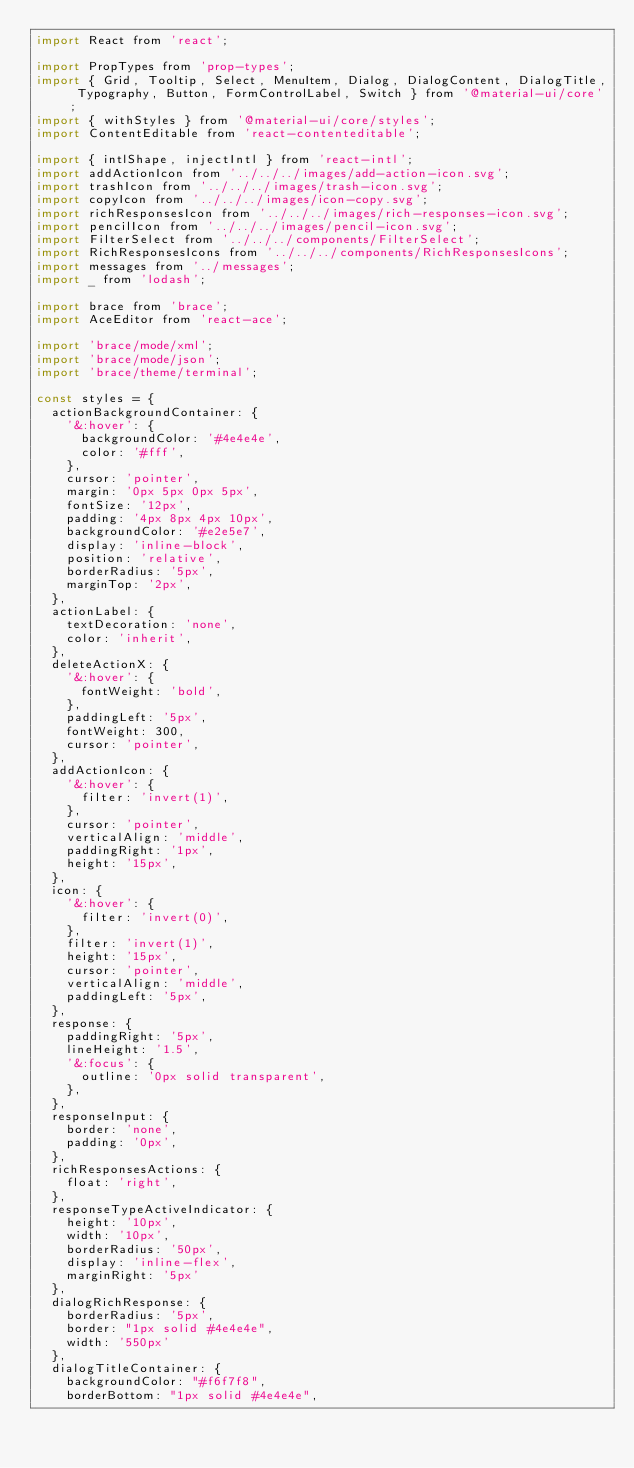<code> <loc_0><loc_0><loc_500><loc_500><_JavaScript_>import React from 'react';

import PropTypes from 'prop-types';
import { Grid, Tooltip, Select, MenuItem, Dialog, DialogContent, DialogTitle, Typography, Button, FormControlLabel, Switch } from '@material-ui/core';
import { withStyles } from '@material-ui/core/styles';
import ContentEditable from 'react-contenteditable';

import { intlShape, injectIntl } from 'react-intl';
import addActionIcon from '../../../images/add-action-icon.svg';
import trashIcon from '../../../images/trash-icon.svg';
import copyIcon from '../../../images/icon-copy.svg';
import richResponsesIcon from '../../../images/rich-responses-icon.svg';
import pencilIcon from '../../../images/pencil-icon.svg';
import FilterSelect from '../../../components/FilterSelect';
import RichResponsesIcons from '../../../components/RichResponsesIcons';
import messages from '../messages';
import _ from 'lodash';

import brace from 'brace';
import AceEditor from 'react-ace';

import 'brace/mode/xml';
import 'brace/mode/json';
import 'brace/theme/terminal';

const styles = {
  actionBackgroundContainer: {
    '&:hover': {
      backgroundColor: '#4e4e4e',
      color: '#fff',
    },
    cursor: 'pointer',
    margin: '0px 5px 0px 5px',
    fontSize: '12px',
    padding: '4px 8px 4px 10px',
    backgroundColor: '#e2e5e7',
    display: 'inline-block',
    position: 'relative',
    borderRadius: '5px',
    marginTop: '2px',
  },
  actionLabel: {
    textDecoration: 'none',
    color: 'inherit',
  },
  deleteActionX: {
    '&:hover': {
      fontWeight: 'bold',
    },
    paddingLeft: '5px',
    fontWeight: 300,
    cursor: 'pointer',
  },
  addActionIcon: {
    '&:hover': {
      filter: 'invert(1)',
    },
    cursor: 'pointer',
    verticalAlign: 'middle',
    paddingRight: '1px',
    height: '15px',
  },
  icon: {
    '&:hover': {
      filter: 'invert(0)',
    },
    filter: 'invert(1)',
    height: '15px',
    cursor: 'pointer',
    verticalAlign: 'middle',
    paddingLeft: '5px',
  },
  response: {
    paddingRight: '5px',
    lineHeight: '1.5',
    '&:focus': {
      outline: '0px solid transparent',
    },
  },
  responseInput: {
    border: 'none',
    padding: '0px',
  },
  richResponsesActions: {
    float: 'right',
  },
  responseTypeActiveIndicator: {
    height: '10px',
    width: '10px',
    borderRadius: '50px',
    display: 'inline-flex',
    marginRight: '5px'
  },
  dialogRichResponse: {
    borderRadius: '5px',
    border: "1px solid #4e4e4e",
    width: '550px'
  },
  dialogTitleContainer: {
    backgroundColor: "#f6f7f8",
    borderBottom: "1px solid #4e4e4e",</code> 